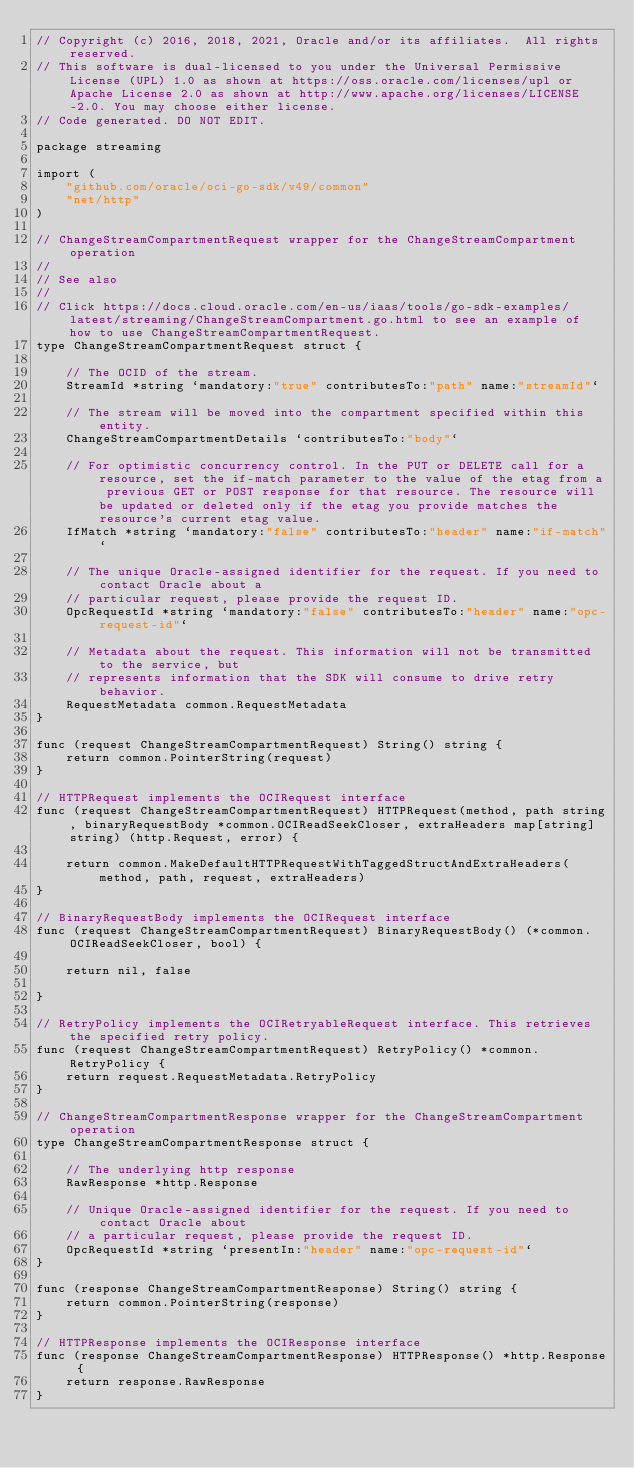Convert code to text. <code><loc_0><loc_0><loc_500><loc_500><_Go_>// Copyright (c) 2016, 2018, 2021, Oracle and/or its affiliates.  All rights reserved.
// This software is dual-licensed to you under the Universal Permissive License (UPL) 1.0 as shown at https://oss.oracle.com/licenses/upl or Apache License 2.0 as shown at http://www.apache.org/licenses/LICENSE-2.0. You may choose either license.
// Code generated. DO NOT EDIT.

package streaming

import (
	"github.com/oracle/oci-go-sdk/v49/common"
	"net/http"
)

// ChangeStreamCompartmentRequest wrapper for the ChangeStreamCompartment operation
//
// See also
//
// Click https://docs.cloud.oracle.com/en-us/iaas/tools/go-sdk-examples/latest/streaming/ChangeStreamCompartment.go.html to see an example of how to use ChangeStreamCompartmentRequest.
type ChangeStreamCompartmentRequest struct {

	// The OCID of the stream.
	StreamId *string `mandatory:"true" contributesTo:"path" name:"streamId"`

	// The stream will be moved into the compartment specified within this entity.
	ChangeStreamCompartmentDetails `contributesTo:"body"`

	// For optimistic concurrency control. In the PUT or DELETE call for a resource, set the if-match parameter to the value of the etag from a previous GET or POST response for that resource. The resource will be updated or deleted only if the etag you provide matches the resource's current etag value.
	IfMatch *string `mandatory:"false" contributesTo:"header" name:"if-match"`

	// The unique Oracle-assigned identifier for the request. If you need to contact Oracle about a
	// particular request, please provide the request ID.
	OpcRequestId *string `mandatory:"false" contributesTo:"header" name:"opc-request-id"`

	// Metadata about the request. This information will not be transmitted to the service, but
	// represents information that the SDK will consume to drive retry behavior.
	RequestMetadata common.RequestMetadata
}

func (request ChangeStreamCompartmentRequest) String() string {
	return common.PointerString(request)
}

// HTTPRequest implements the OCIRequest interface
func (request ChangeStreamCompartmentRequest) HTTPRequest(method, path string, binaryRequestBody *common.OCIReadSeekCloser, extraHeaders map[string]string) (http.Request, error) {

	return common.MakeDefaultHTTPRequestWithTaggedStructAndExtraHeaders(method, path, request, extraHeaders)
}

// BinaryRequestBody implements the OCIRequest interface
func (request ChangeStreamCompartmentRequest) BinaryRequestBody() (*common.OCIReadSeekCloser, bool) {

	return nil, false

}

// RetryPolicy implements the OCIRetryableRequest interface. This retrieves the specified retry policy.
func (request ChangeStreamCompartmentRequest) RetryPolicy() *common.RetryPolicy {
	return request.RequestMetadata.RetryPolicy
}

// ChangeStreamCompartmentResponse wrapper for the ChangeStreamCompartment operation
type ChangeStreamCompartmentResponse struct {

	// The underlying http response
	RawResponse *http.Response

	// Unique Oracle-assigned identifier for the request. If you need to contact Oracle about
	// a particular request, please provide the request ID.
	OpcRequestId *string `presentIn:"header" name:"opc-request-id"`
}

func (response ChangeStreamCompartmentResponse) String() string {
	return common.PointerString(response)
}

// HTTPResponse implements the OCIResponse interface
func (response ChangeStreamCompartmentResponse) HTTPResponse() *http.Response {
	return response.RawResponse
}
</code> 